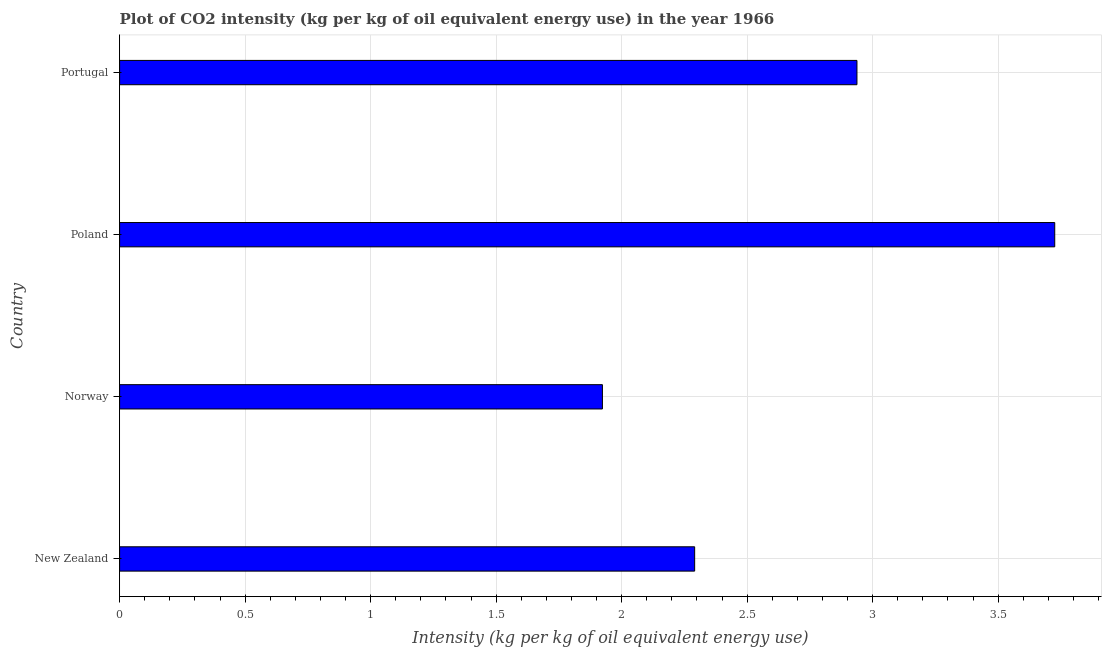Does the graph contain any zero values?
Keep it short and to the point. No. Does the graph contain grids?
Make the answer very short. Yes. What is the title of the graph?
Your response must be concise. Plot of CO2 intensity (kg per kg of oil equivalent energy use) in the year 1966. What is the label or title of the X-axis?
Provide a succinct answer. Intensity (kg per kg of oil equivalent energy use). What is the label or title of the Y-axis?
Make the answer very short. Country. What is the co2 intensity in Portugal?
Make the answer very short. 2.94. Across all countries, what is the maximum co2 intensity?
Offer a very short reply. 3.73. Across all countries, what is the minimum co2 intensity?
Your response must be concise. 1.92. In which country was the co2 intensity maximum?
Your answer should be very brief. Poland. In which country was the co2 intensity minimum?
Make the answer very short. Norway. What is the sum of the co2 intensity?
Offer a terse response. 10.88. What is the difference between the co2 intensity in New Zealand and Portugal?
Your response must be concise. -0.65. What is the average co2 intensity per country?
Keep it short and to the point. 2.72. What is the median co2 intensity?
Make the answer very short. 2.61. In how many countries, is the co2 intensity greater than 2.1 kg?
Your response must be concise. 3. What is the ratio of the co2 intensity in New Zealand to that in Norway?
Make the answer very short. 1.19. What is the difference between the highest and the second highest co2 intensity?
Your response must be concise. 0.79. Is the sum of the co2 intensity in Poland and Portugal greater than the maximum co2 intensity across all countries?
Make the answer very short. Yes. How many bars are there?
Offer a terse response. 4. How many countries are there in the graph?
Your response must be concise. 4. What is the difference between two consecutive major ticks on the X-axis?
Offer a terse response. 0.5. What is the Intensity (kg per kg of oil equivalent energy use) of New Zealand?
Your response must be concise. 2.29. What is the Intensity (kg per kg of oil equivalent energy use) in Norway?
Provide a succinct answer. 1.92. What is the Intensity (kg per kg of oil equivalent energy use) in Poland?
Your answer should be compact. 3.73. What is the Intensity (kg per kg of oil equivalent energy use) in Portugal?
Your answer should be compact. 2.94. What is the difference between the Intensity (kg per kg of oil equivalent energy use) in New Zealand and Norway?
Provide a short and direct response. 0.37. What is the difference between the Intensity (kg per kg of oil equivalent energy use) in New Zealand and Poland?
Provide a short and direct response. -1.43. What is the difference between the Intensity (kg per kg of oil equivalent energy use) in New Zealand and Portugal?
Ensure brevity in your answer.  -0.65. What is the difference between the Intensity (kg per kg of oil equivalent energy use) in Norway and Poland?
Keep it short and to the point. -1.8. What is the difference between the Intensity (kg per kg of oil equivalent energy use) in Norway and Portugal?
Make the answer very short. -1.01. What is the difference between the Intensity (kg per kg of oil equivalent energy use) in Poland and Portugal?
Make the answer very short. 0.79. What is the ratio of the Intensity (kg per kg of oil equivalent energy use) in New Zealand to that in Norway?
Make the answer very short. 1.19. What is the ratio of the Intensity (kg per kg of oil equivalent energy use) in New Zealand to that in Poland?
Give a very brief answer. 0.61. What is the ratio of the Intensity (kg per kg of oil equivalent energy use) in New Zealand to that in Portugal?
Your answer should be compact. 0.78. What is the ratio of the Intensity (kg per kg of oil equivalent energy use) in Norway to that in Poland?
Your answer should be very brief. 0.52. What is the ratio of the Intensity (kg per kg of oil equivalent energy use) in Norway to that in Portugal?
Provide a succinct answer. 0.66. What is the ratio of the Intensity (kg per kg of oil equivalent energy use) in Poland to that in Portugal?
Make the answer very short. 1.27. 